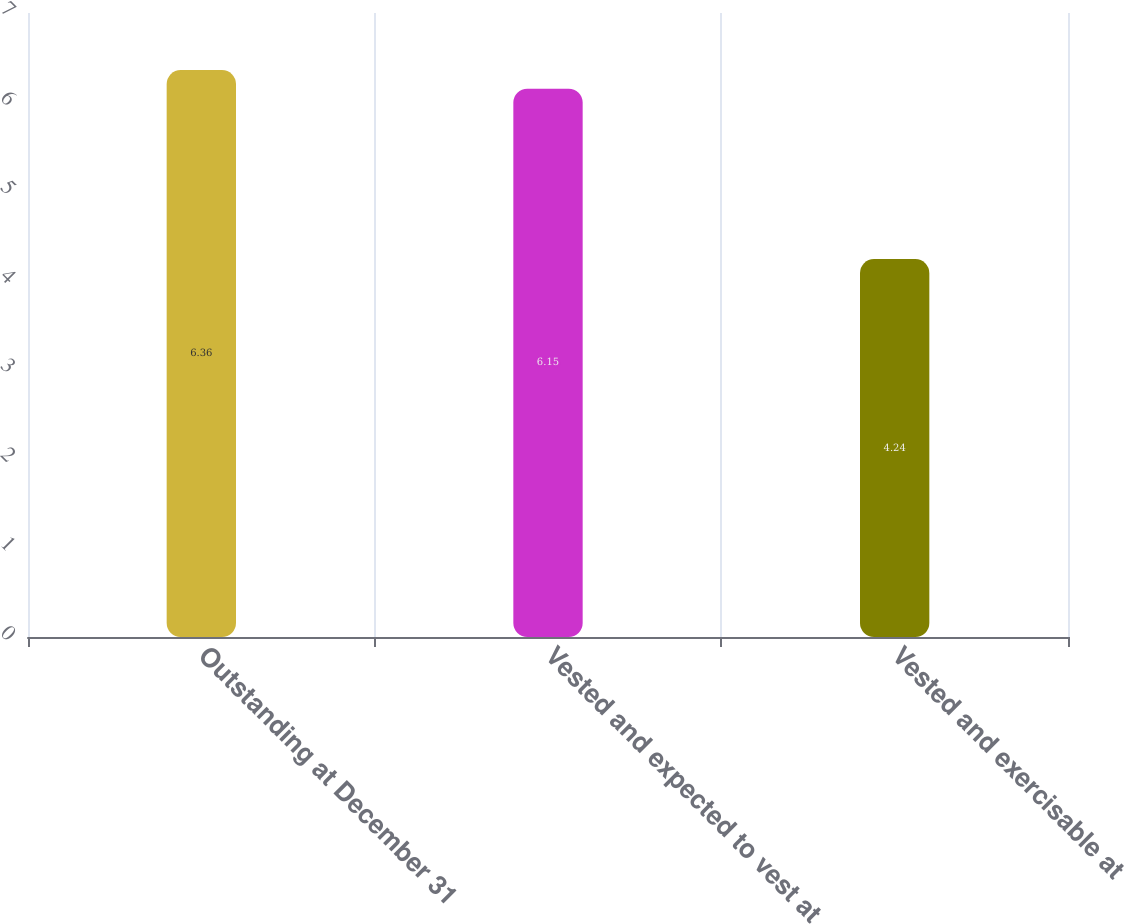<chart> <loc_0><loc_0><loc_500><loc_500><bar_chart><fcel>Outstanding at December 31<fcel>Vested and expected to vest at<fcel>Vested and exercisable at<nl><fcel>6.36<fcel>6.15<fcel>4.24<nl></chart> 